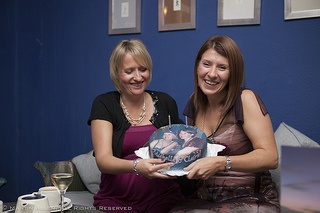Describe the objects in this image and their specific colors. I can see people in black, maroon, gray, and brown tones, people in black, gray, and maroon tones, couch in black and gray tones, cake in black, gray, darkgray, and lightgray tones, and cup in black, lightgray, darkgray, and gray tones in this image. 